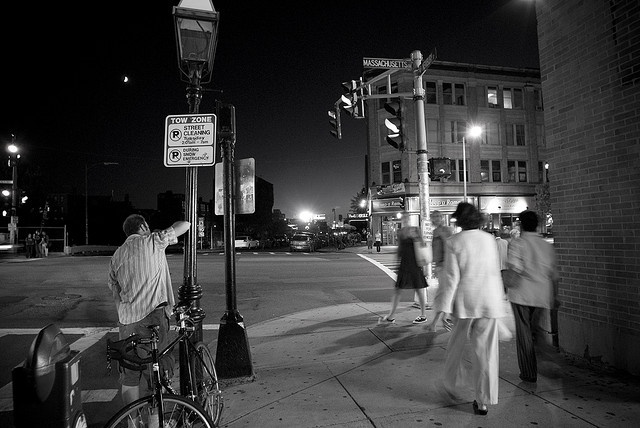Describe the objects in this image and their specific colors. I can see people in black, gray, lightgray, and darkgray tones, people in black, gray, darkgray, and lightgray tones, parking meter in black, gray, darkgray, and lightgray tones, people in black, dimgray, gray, and lightgray tones, and bicycle in black, gray, darkgray, and gainsboro tones in this image. 